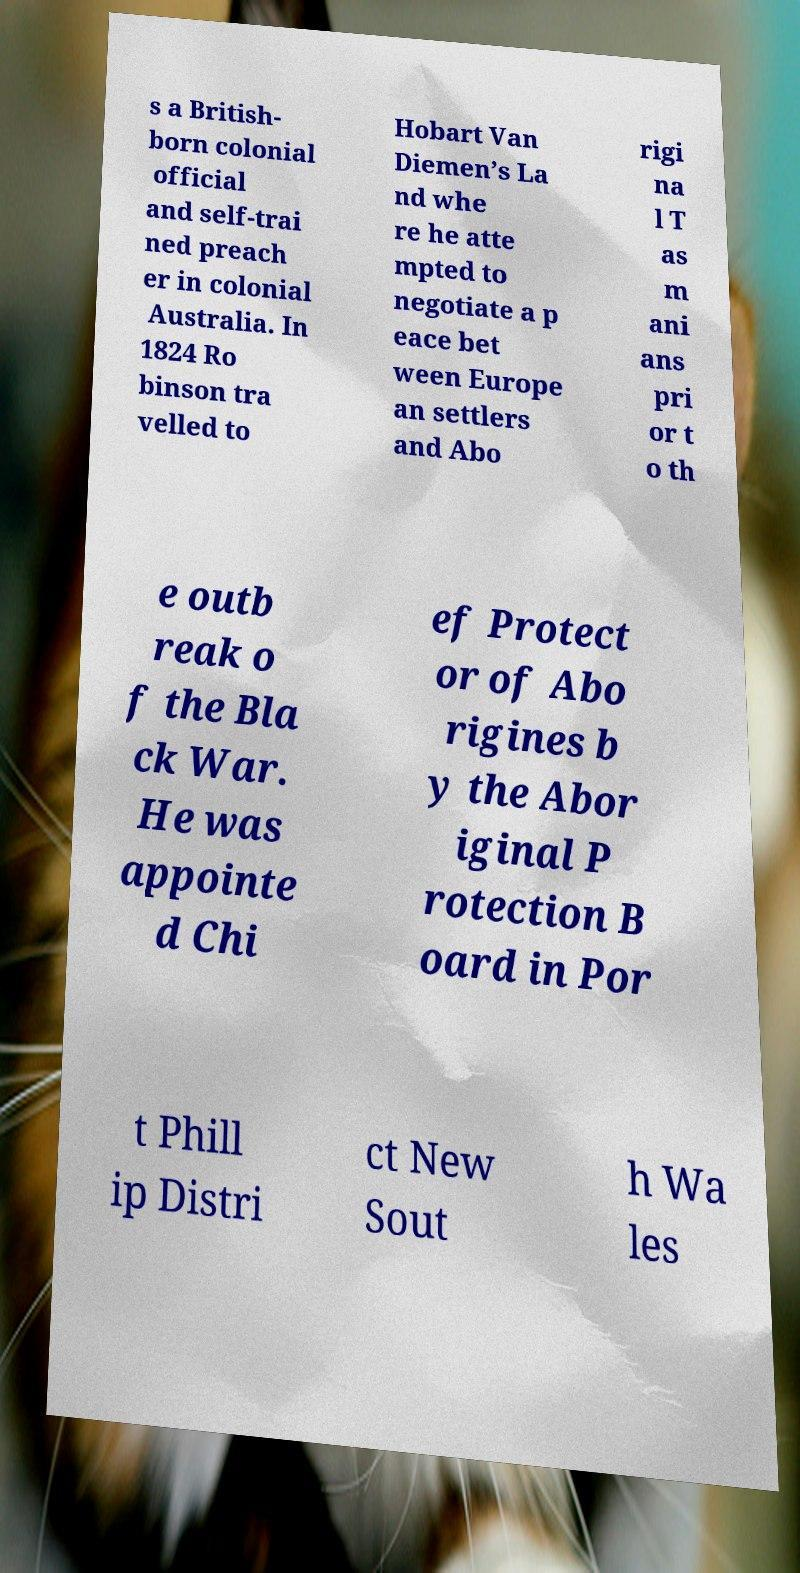I need the written content from this picture converted into text. Can you do that? s a British- born colonial official and self-trai ned preach er in colonial Australia. In 1824 Ro binson tra velled to Hobart Van Diemen’s La nd whe re he atte mpted to negotiate a p eace bet ween Europe an settlers and Abo rigi na l T as m ani ans pri or t o th e outb reak o f the Bla ck War. He was appointe d Chi ef Protect or of Abo rigines b y the Abor iginal P rotection B oard in Por t Phill ip Distri ct New Sout h Wa les 